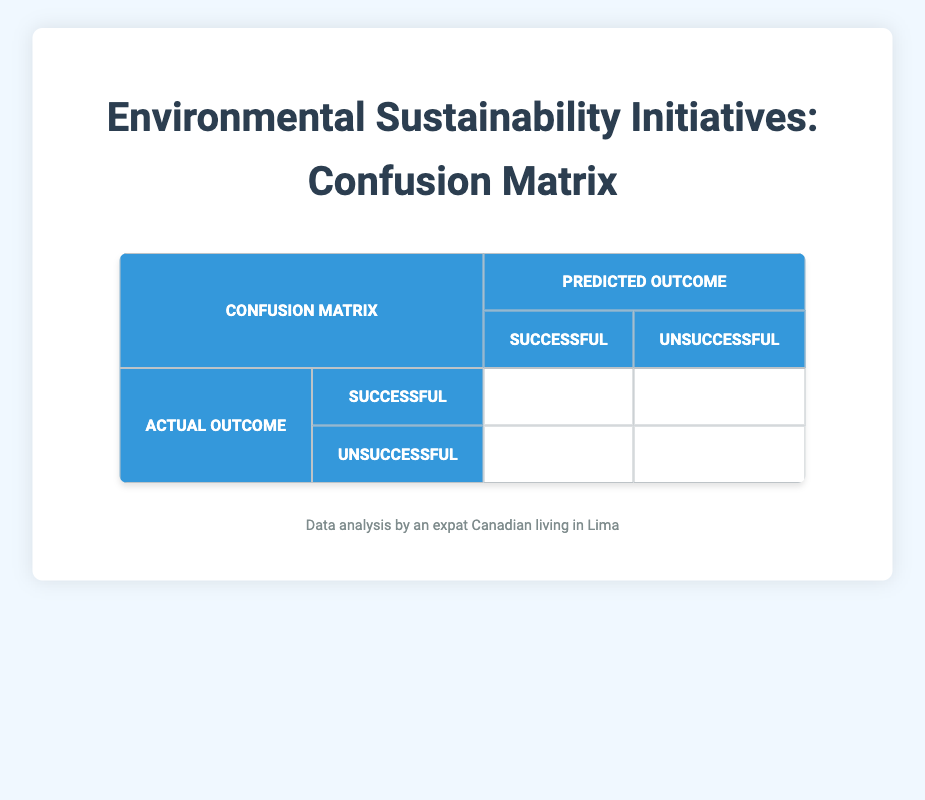What is the total number of successful outcomes predicted by the initiatives? From the confusion matrix, we can observe that the number of successful outcomes, which are the true positives and the false negatives, are 3 (true positives) and 1 (false negatives). Adding these together gives us 3 + 1 = 4.
Answer: 4 What is the total number of unsuccessful outcomes predicted by the initiatives? Looking at the confusion matrix, the unsuccessful outcomes consist of 2 (false positives) and 4 (true negatives). When we add these two values, we have 2 + 4 = 6.
Answer: 6 Did more expatriates or locals support the initiatives successfully? The confusion matrix shows that there are 3 successful outcomes (true positives) and among them, 2 are locals and 1 is an expatriate. Thus, locals had a higher number of successful outcomes.
Answer: Locals What is the number of false positives? The confusion matrix directly shows that there are 2 false positives indicated in the table. Therefore, the number of false positives is simply 2.
Answer: 2 Is it true that there were more successful initiatives than unsuccessful ones? By evaluating all the outcomes, we see that there are 4 successful outcomes (3 true positives and 1 false negative) and 6 unsuccessful outcomes (2 false positives and 4 true negatives). Since 4 is less than 6, the statement is false.
Answer: No What is the compliance rate (percentage) of successful initiatives out of the total initiatives? To find the compliance rate, we can total the successful initiatives (4) and divide by the total number of participants (10), which gives us (4/10) * 100 = 40%. Therefore, the compliance rate is 40%.
Answer: 40% How many expatriates participated in the initiatives that were ultimately unsuccessful? Looking at the confusion matrix and counting the relevant categories, we see that there are 4 unsuccessful outcomes in total: 2 are expatriates. Therefore, the number of expatriates in unsuccessful initiatives is 2.
Answer: 2 What is the number of locals who supported the initiatives but ended up unsuccessful? From the confusion matrix, we note that there is 1 local who supported but ended up unsuccessful (indicated as a false positive). Thus, the total is 1.
Answer: 1 Which outcome category (successful or unsuccessful) has the highest representation in the table? By adding the totals, we find that there are 4 successful outcomes (3 true positives + 1 false negative) and 6 unsuccessful outcomes (2 false positives + 4 true negatives). Since 6 is greater than 4, the highest representation is in the unsuccessful category.
Answer: Unsuccessful 